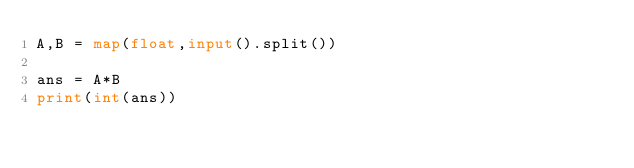<code> <loc_0><loc_0><loc_500><loc_500><_Python_>A,B = map(float,input().split())

ans = A*B
print(int(ans))</code> 